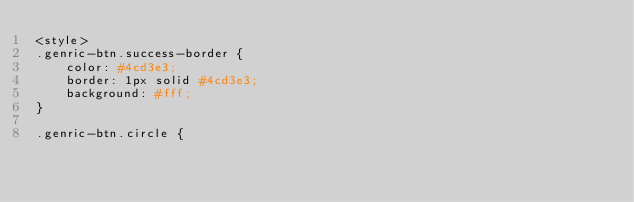Convert code to text. <code><loc_0><loc_0><loc_500><loc_500><_PHP_><style>
.genric-btn.success-border {
    color: #4cd3e3;
    border: 1px solid #4cd3e3;
    background: #fff;
}

.genric-btn.circle {</code> 